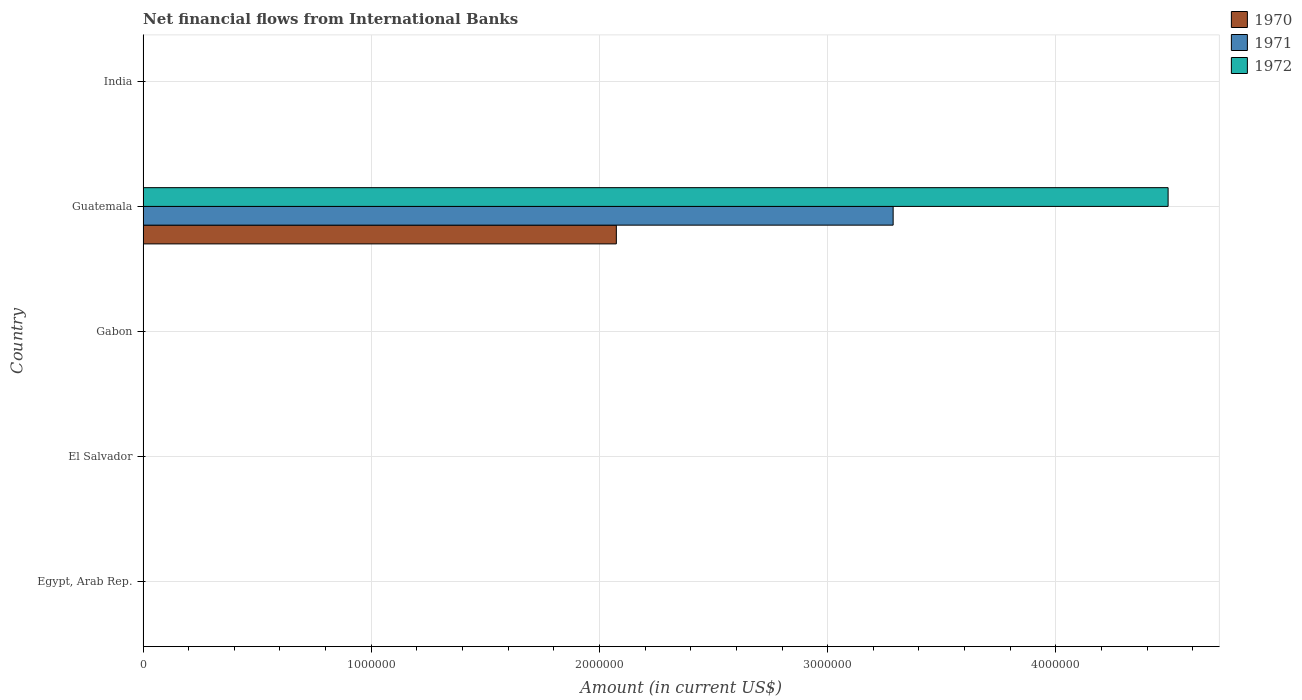Are the number of bars per tick equal to the number of legend labels?
Your answer should be compact. No. What is the label of the 1st group of bars from the top?
Your answer should be very brief. India. In how many cases, is the number of bars for a given country not equal to the number of legend labels?
Provide a short and direct response. 4. Across all countries, what is the maximum net financial aid flows in 1972?
Your response must be concise. 4.49e+06. In which country was the net financial aid flows in 1971 maximum?
Make the answer very short. Guatemala. What is the total net financial aid flows in 1972 in the graph?
Make the answer very short. 4.49e+06. What is the difference between the net financial aid flows in 1971 in Guatemala and the net financial aid flows in 1970 in Gabon?
Keep it short and to the point. 3.29e+06. What is the average net financial aid flows in 1970 per country?
Your response must be concise. 4.15e+05. What is the difference between the highest and the lowest net financial aid flows in 1971?
Keep it short and to the point. 3.29e+06. How many countries are there in the graph?
Give a very brief answer. 5. Are the values on the major ticks of X-axis written in scientific E-notation?
Provide a short and direct response. No. Does the graph contain any zero values?
Offer a terse response. Yes. Does the graph contain grids?
Give a very brief answer. Yes. Where does the legend appear in the graph?
Your answer should be compact. Top right. How are the legend labels stacked?
Make the answer very short. Vertical. What is the title of the graph?
Make the answer very short. Net financial flows from International Banks. Does "1991" appear as one of the legend labels in the graph?
Provide a short and direct response. No. What is the label or title of the Y-axis?
Offer a very short reply. Country. What is the Amount (in current US$) in 1972 in Egypt, Arab Rep.?
Provide a succinct answer. 0. What is the Amount (in current US$) of 1972 in El Salvador?
Offer a very short reply. 0. What is the Amount (in current US$) in 1970 in Gabon?
Give a very brief answer. 0. What is the Amount (in current US$) in 1970 in Guatemala?
Offer a terse response. 2.07e+06. What is the Amount (in current US$) in 1971 in Guatemala?
Keep it short and to the point. 3.29e+06. What is the Amount (in current US$) of 1972 in Guatemala?
Ensure brevity in your answer.  4.49e+06. What is the Amount (in current US$) of 1971 in India?
Your answer should be very brief. 0. Across all countries, what is the maximum Amount (in current US$) of 1970?
Provide a short and direct response. 2.07e+06. Across all countries, what is the maximum Amount (in current US$) of 1971?
Keep it short and to the point. 3.29e+06. Across all countries, what is the maximum Amount (in current US$) in 1972?
Provide a short and direct response. 4.49e+06. Across all countries, what is the minimum Amount (in current US$) in 1970?
Your answer should be very brief. 0. Across all countries, what is the minimum Amount (in current US$) of 1971?
Provide a short and direct response. 0. Across all countries, what is the minimum Amount (in current US$) of 1972?
Make the answer very short. 0. What is the total Amount (in current US$) in 1970 in the graph?
Make the answer very short. 2.07e+06. What is the total Amount (in current US$) in 1971 in the graph?
Offer a terse response. 3.29e+06. What is the total Amount (in current US$) in 1972 in the graph?
Provide a succinct answer. 4.49e+06. What is the average Amount (in current US$) of 1970 per country?
Give a very brief answer. 4.15e+05. What is the average Amount (in current US$) of 1971 per country?
Make the answer very short. 6.57e+05. What is the average Amount (in current US$) of 1972 per country?
Provide a short and direct response. 8.98e+05. What is the difference between the Amount (in current US$) in 1970 and Amount (in current US$) in 1971 in Guatemala?
Your answer should be compact. -1.21e+06. What is the difference between the Amount (in current US$) of 1970 and Amount (in current US$) of 1972 in Guatemala?
Offer a terse response. -2.42e+06. What is the difference between the Amount (in current US$) in 1971 and Amount (in current US$) in 1972 in Guatemala?
Ensure brevity in your answer.  -1.20e+06. What is the difference between the highest and the lowest Amount (in current US$) in 1970?
Keep it short and to the point. 2.07e+06. What is the difference between the highest and the lowest Amount (in current US$) in 1971?
Your answer should be very brief. 3.29e+06. What is the difference between the highest and the lowest Amount (in current US$) of 1972?
Keep it short and to the point. 4.49e+06. 